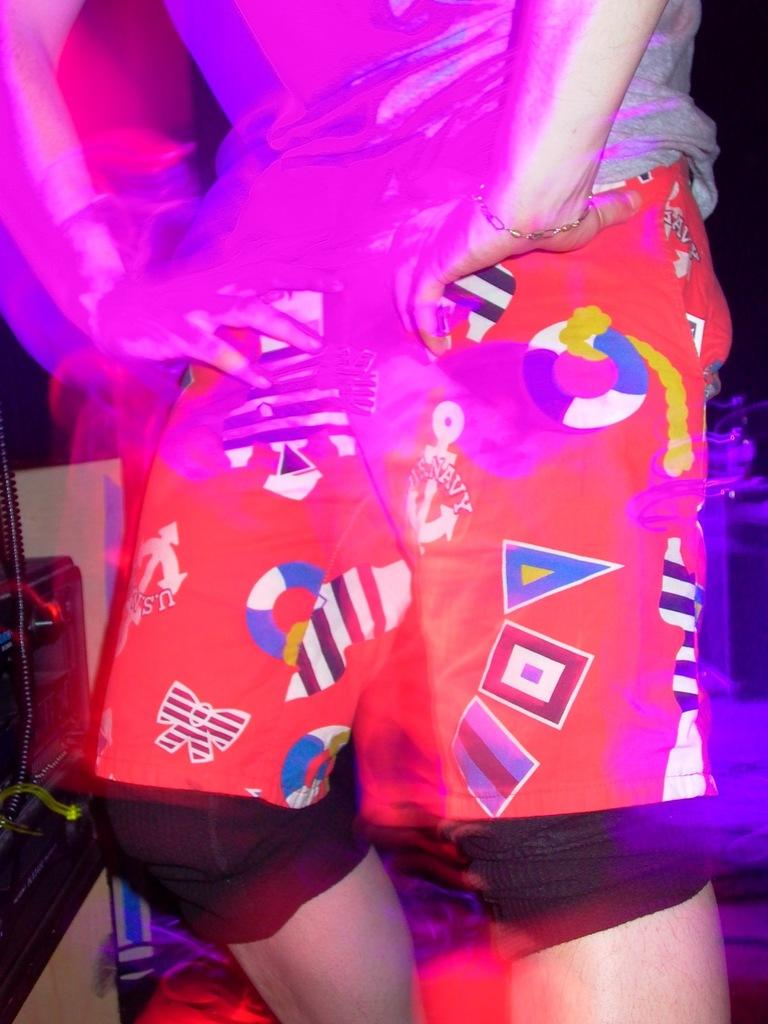What is the main subject in the image? There is a person standing in the image. Where are the objects located in the image? There are objects on the left side and the bottom of the image. How would you describe the background of the image? The background of the image is dark. What type of brick is being used to create the art in the image? There is no brick or art present in the image; it features a person standing with objects on the left side and the bottom. 